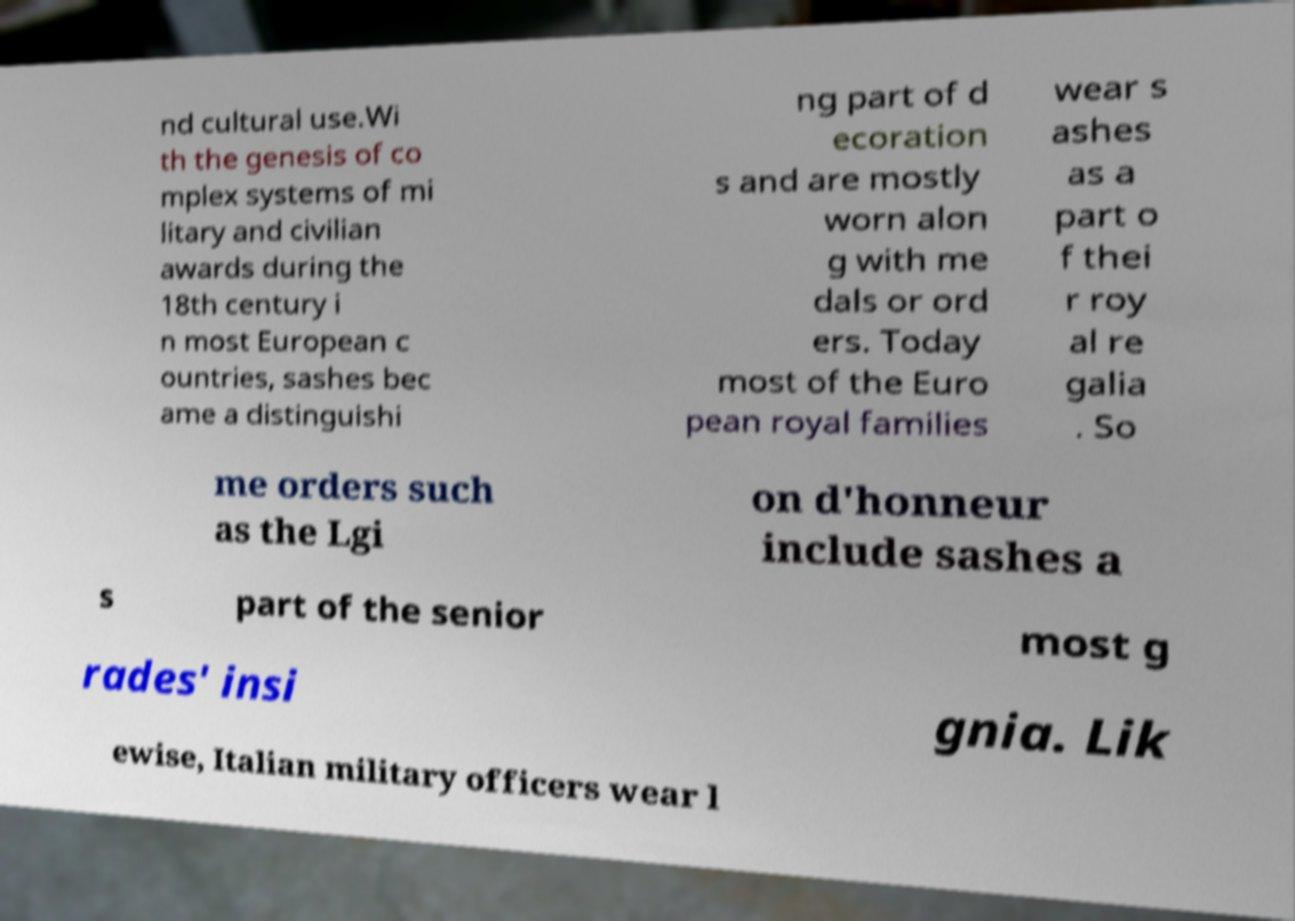For documentation purposes, I need the text within this image transcribed. Could you provide that? nd cultural use.Wi th the genesis of co mplex systems of mi litary and civilian awards during the 18th century i n most European c ountries, sashes bec ame a distinguishi ng part of d ecoration s and are mostly worn alon g with me dals or ord ers. Today most of the Euro pean royal families wear s ashes as a part o f thei r roy al re galia . So me orders such as the Lgi on d'honneur include sashes a s part of the senior most g rades' insi gnia. Lik ewise, Italian military officers wear l 